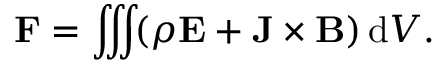<formula> <loc_0><loc_0><loc_500><loc_500>F = \iiint \, ( \rho E + J \times B ) \, d V . \,</formula> 